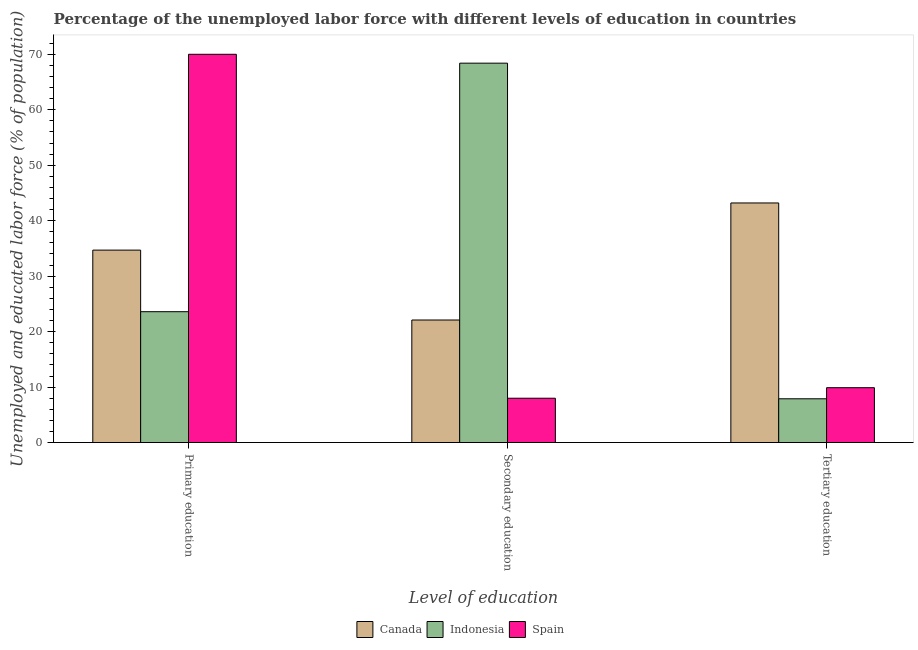How many different coloured bars are there?
Keep it short and to the point. 3. Are the number of bars on each tick of the X-axis equal?
Provide a short and direct response. Yes. What is the label of the 3rd group of bars from the left?
Offer a terse response. Tertiary education. What is the percentage of labor force who received secondary education in Spain?
Keep it short and to the point. 8. Across all countries, what is the maximum percentage of labor force who received secondary education?
Make the answer very short. 68.4. What is the total percentage of labor force who received tertiary education in the graph?
Make the answer very short. 61. What is the difference between the percentage of labor force who received tertiary education in Canada and that in Indonesia?
Keep it short and to the point. 35.3. What is the difference between the percentage of labor force who received secondary education in Canada and the percentage of labor force who received primary education in Spain?
Your answer should be very brief. -47.9. What is the average percentage of labor force who received primary education per country?
Give a very brief answer. 42.77. What is the difference between the percentage of labor force who received tertiary education and percentage of labor force who received primary education in Indonesia?
Offer a very short reply. -15.7. What is the ratio of the percentage of labor force who received tertiary education in Canada to that in Indonesia?
Make the answer very short. 5.47. Is the difference between the percentage of labor force who received tertiary education in Canada and Spain greater than the difference between the percentage of labor force who received primary education in Canada and Spain?
Offer a very short reply. Yes. What is the difference between the highest and the second highest percentage of labor force who received secondary education?
Ensure brevity in your answer.  46.3. What is the difference between the highest and the lowest percentage of labor force who received secondary education?
Ensure brevity in your answer.  60.4. What does the 2nd bar from the left in Tertiary education represents?
Provide a succinct answer. Indonesia. What does the 2nd bar from the right in Primary education represents?
Your answer should be compact. Indonesia. Is it the case that in every country, the sum of the percentage of labor force who received primary education and percentage of labor force who received secondary education is greater than the percentage of labor force who received tertiary education?
Your answer should be compact. Yes. Are all the bars in the graph horizontal?
Your answer should be compact. No. How many countries are there in the graph?
Make the answer very short. 3. What is the difference between two consecutive major ticks on the Y-axis?
Offer a very short reply. 10. Are the values on the major ticks of Y-axis written in scientific E-notation?
Make the answer very short. No. Does the graph contain grids?
Offer a very short reply. No. How are the legend labels stacked?
Ensure brevity in your answer.  Horizontal. What is the title of the graph?
Ensure brevity in your answer.  Percentage of the unemployed labor force with different levels of education in countries. What is the label or title of the X-axis?
Make the answer very short. Level of education. What is the label or title of the Y-axis?
Provide a short and direct response. Unemployed and educated labor force (% of population). What is the Unemployed and educated labor force (% of population) in Canada in Primary education?
Provide a succinct answer. 34.7. What is the Unemployed and educated labor force (% of population) of Indonesia in Primary education?
Provide a succinct answer. 23.6. What is the Unemployed and educated labor force (% of population) in Canada in Secondary education?
Keep it short and to the point. 22.1. What is the Unemployed and educated labor force (% of population) of Indonesia in Secondary education?
Ensure brevity in your answer.  68.4. What is the Unemployed and educated labor force (% of population) of Spain in Secondary education?
Your response must be concise. 8. What is the Unemployed and educated labor force (% of population) in Canada in Tertiary education?
Offer a terse response. 43.2. What is the Unemployed and educated labor force (% of population) of Indonesia in Tertiary education?
Offer a very short reply. 7.9. What is the Unemployed and educated labor force (% of population) in Spain in Tertiary education?
Provide a short and direct response. 9.9. Across all Level of education, what is the maximum Unemployed and educated labor force (% of population) of Canada?
Provide a succinct answer. 43.2. Across all Level of education, what is the maximum Unemployed and educated labor force (% of population) of Indonesia?
Give a very brief answer. 68.4. Across all Level of education, what is the maximum Unemployed and educated labor force (% of population) of Spain?
Offer a very short reply. 70. Across all Level of education, what is the minimum Unemployed and educated labor force (% of population) in Canada?
Your response must be concise. 22.1. Across all Level of education, what is the minimum Unemployed and educated labor force (% of population) in Indonesia?
Give a very brief answer. 7.9. Across all Level of education, what is the minimum Unemployed and educated labor force (% of population) of Spain?
Provide a succinct answer. 8. What is the total Unemployed and educated labor force (% of population) of Canada in the graph?
Provide a succinct answer. 100. What is the total Unemployed and educated labor force (% of population) in Indonesia in the graph?
Give a very brief answer. 99.9. What is the total Unemployed and educated labor force (% of population) in Spain in the graph?
Ensure brevity in your answer.  87.9. What is the difference between the Unemployed and educated labor force (% of population) in Canada in Primary education and that in Secondary education?
Your answer should be compact. 12.6. What is the difference between the Unemployed and educated labor force (% of population) of Indonesia in Primary education and that in Secondary education?
Give a very brief answer. -44.8. What is the difference between the Unemployed and educated labor force (% of population) in Spain in Primary education and that in Secondary education?
Your answer should be very brief. 62. What is the difference between the Unemployed and educated labor force (% of population) of Canada in Primary education and that in Tertiary education?
Keep it short and to the point. -8.5. What is the difference between the Unemployed and educated labor force (% of population) of Indonesia in Primary education and that in Tertiary education?
Offer a terse response. 15.7. What is the difference between the Unemployed and educated labor force (% of population) of Spain in Primary education and that in Tertiary education?
Offer a very short reply. 60.1. What is the difference between the Unemployed and educated labor force (% of population) in Canada in Secondary education and that in Tertiary education?
Give a very brief answer. -21.1. What is the difference between the Unemployed and educated labor force (% of population) of Indonesia in Secondary education and that in Tertiary education?
Offer a very short reply. 60.5. What is the difference between the Unemployed and educated labor force (% of population) of Canada in Primary education and the Unemployed and educated labor force (% of population) of Indonesia in Secondary education?
Keep it short and to the point. -33.7. What is the difference between the Unemployed and educated labor force (% of population) of Canada in Primary education and the Unemployed and educated labor force (% of population) of Spain in Secondary education?
Offer a very short reply. 26.7. What is the difference between the Unemployed and educated labor force (% of population) of Canada in Primary education and the Unemployed and educated labor force (% of population) of Indonesia in Tertiary education?
Keep it short and to the point. 26.8. What is the difference between the Unemployed and educated labor force (% of population) in Canada in Primary education and the Unemployed and educated labor force (% of population) in Spain in Tertiary education?
Keep it short and to the point. 24.8. What is the difference between the Unemployed and educated labor force (% of population) in Canada in Secondary education and the Unemployed and educated labor force (% of population) in Spain in Tertiary education?
Ensure brevity in your answer.  12.2. What is the difference between the Unemployed and educated labor force (% of population) of Indonesia in Secondary education and the Unemployed and educated labor force (% of population) of Spain in Tertiary education?
Your answer should be very brief. 58.5. What is the average Unemployed and educated labor force (% of population) of Canada per Level of education?
Provide a succinct answer. 33.33. What is the average Unemployed and educated labor force (% of population) of Indonesia per Level of education?
Keep it short and to the point. 33.3. What is the average Unemployed and educated labor force (% of population) in Spain per Level of education?
Keep it short and to the point. 29.3. What is the difference between the Unemployed and educated labor force (% of population) in Canada and Unemployed and educated labor force (% of population) in Indonesia in Primary education?
Give a very brief answer. 11.1. What is the difference between the Unemployed and educated labor force (% of population) of Canada and Unemployed and educated labor force (% of population) of Spain in Primary education?
Your answer should be compact. -35.3. What is the difference between the Unemployed and educated labor force (% of population) in Indonesia and Unemployed and educated labor force (% of population) in Spain in Primary education?
Your response must be concise. -46.4. What is the difference between the Unemployed and educated labor force (% of population) of Canada and Unemployed and educated labor force (% of population) of Indonesia in Secondary education?
Your response must be concise. -46.3. What is the difference between the Unemployed and educated labor force (% of population) of Indonesia and Unemployed and educated labor force (% of population) of Spain in Secondary education?
Your answer should be very brief. 60.4. What is the difference between the Unemployed and educated labor force (% of population) in Canada and Unemployed and educated labor force (% of population) in Indonesia in Tertiary education?
Your answer should be compact. 35.3. What is the difference between the Unemployed and educated labor force (% of population) in Canada and Unemployed and educated labor force (% of population) in Spain in Tertiary education?
Ensure brevity in your answer.  33.3. What is the difference between the Unemployed and educated labor force (% of population) in Indonesia and Unemployed and educated labor force (% of population) in Spain in Tertiary education?
Make the answer very short. -2. What is the ratio of the Unemployed and educated labor force (% of population) of Canada in Primary education to that in Secondary education?
Provide a short and direct response. 1.57. What is the ratio of the Unemployed and educated labor force (% of population) in Indonesia in Primary education to that in Secondary education?
Offer a very short reply. 0.34. What is the ratio of the Unemployed and educated labor force (% of population) of Spain in Primary education to that in Secondary education?
Offer a terse response. 8.75. What is the ratio of the Unemployed and educated labor force (% of population) in Canada in Primary education to that in Tertiary education?
Give a very brief answer. 0.8. What is the ratio of the Unemployed and educated labor force (% of population) in Indonesia in Primary education to that in Tertiary education?
Make the answer very short. 2.99. What is the ratio of the Unemployed and educated labor force (% of population) in Spain in Primary education to that in Tertiary education?
Keep it short and to the point. 7.07. What is the ratio of the Unemployed and educated labor force (% of population) of Canada in Secondary education to that in Tertiary education?
Make the answer very short. 0.51. What is the ratio of the Unemployed and educated labor force (% of population) in Indonesia in Secondary education to that in Tertiary education?
Provide a short and direct response. 8.66. What is the ratio of the Unemployed and educated labor force (% of population) in Spain in Secondary education to that in Tertiary education?
Ensure brevity in your answer.  0.81. What is the difference between the highest and the second highest Unemployed and educated labor force (% of population) of Canada?
Your response must be concise. 8.5. What is the difference between the highest and the second highest Unemployed and educated labor force (% of population) of Indonesia?
Ensure brevity in your answer.  44.8. What is the difference between the highest and the second highest Unemployed and educated labor force (% of population) in Spain?
Your answer should be compact. 60.1. What is the difference between the highest and the lowest Unemployed and educated labor force (% of population) in Canada?
Your answer should be compact. 21.1. What is the difference between the highest and the lowest Unemployed and educated labor force (% of population) in Indonesia?
Give a very brief answer. 60.5. What is the difference between the highest and the lowest Unemployed and educated labor force (% of population) in Spain?
Your response must be concise. 62. 